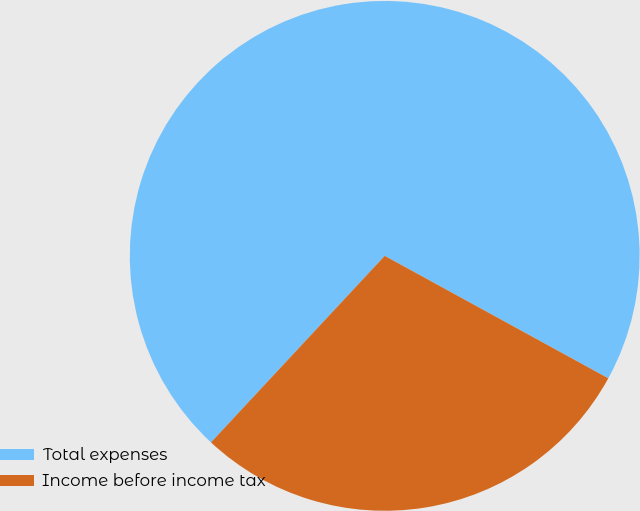Convert chart to OTSL. <chart><loc_0><loc_0><loc_500><loc_500><pie_chart><fcel>Total expenses<fcel>Income before income tax<nl><fcel>71.04%<fcel>28.96%<nl></chart> 